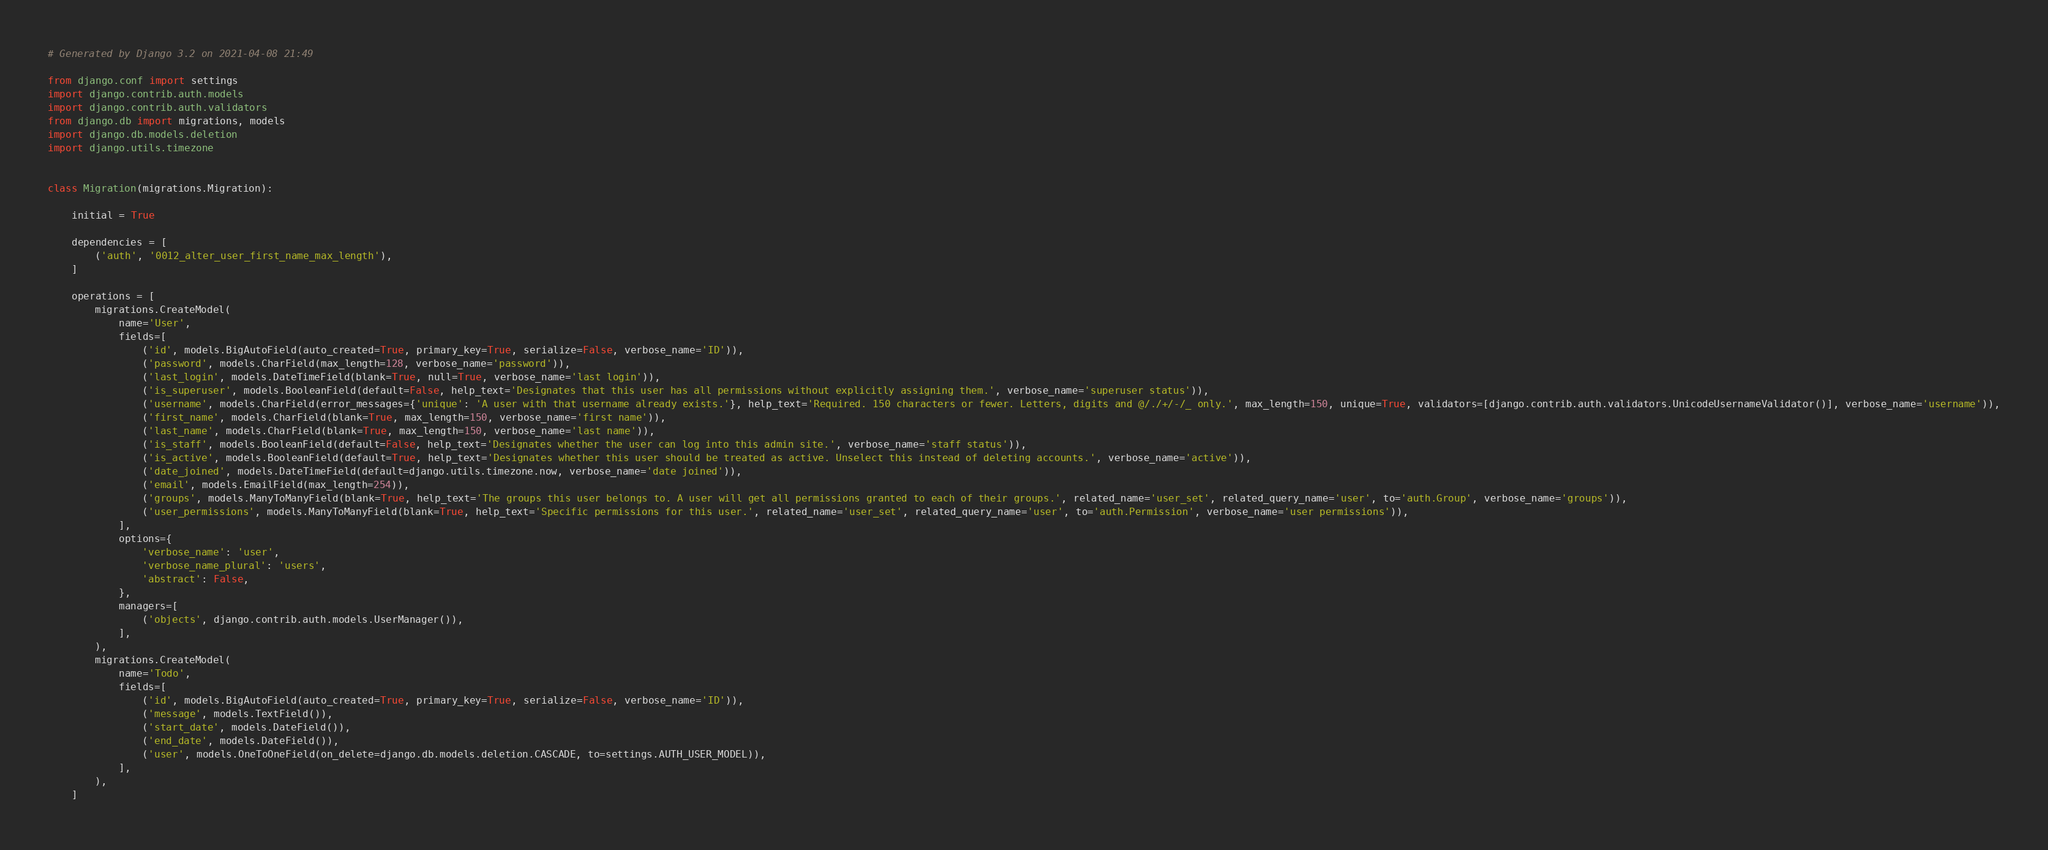<code> <loc_0><loc_0><loc_500><loc_500><_Python_># Generated by Django 3.2 on 2021-04-08 21:49

from django.conf import settings
import django.contrib.auth.models
import django.contrib.auth.validators
from django.db import migrations, models
import django.db.models.deletion
import django.utils.timezone


class Migration(migrations.Migration):

    initial = True

    dependencies = [
        ('auth', '0012_alter_user_first_name_max_length'),
    ]

    operations = [
        migrations.CreateModel(
            name='User',
            fields=[
                ('id', models.BigAutoField(auto_created=True, primary_key=True, serialize=False, verbose_name='ID')),
                ('password', models.CharField(max_length=128, verbose_name='password')),
                ('last_login', models.DateTimeField(blank=True, null=True, verbose_name='last login')),
                ('is_superuser', models.BooleanField(default=False, help_text='Designates that this user has all permissions without explicitly assigning them.', verbose_name='superuser status')),
                ('username', models.CharField(error_messages={'unique': 'A user with that username already exists.'}, help_text='Required. 150 characters or fewer. Letters, digits and @/./+/-/_ only.', max_length=150, unique=True, validators=[django.contrib.auth.validators.UnicodeUsernameValidator()], verbose_name='username')),
                ('first_name', models.CharField(blank=True, max_length=150, verbose_name='first name')),
                ('last_name', models.CharField(blank=True, max_length=150, verbose_name='last name')),
                ('is_staff', models.BooleanField(default=False, help_text='Designates whether the user can log into this admin site.', verbose_name='staff status')),
                ('is_active', models.BooleanField(default=True, help_text='Designates whether this user should be treated as active. Unselect this instead of deleting accounts.', verbose_name='active')),
                ('date_joined', models.DateTimeField(default=django.utils.timezone.now, verbose_name='date joined')),
                ('email', models.EmailField(max_length=254)),
                ('groups', models.ManyToManyField(blank=True, help_text='The groups this user belongs to. A user will get all permissions granted to each of their groups.', related_name='user_set', related_query_name='user', to='auth.Group', verbose_name='groups')),
                ('user_permissions', models.ManyToManyField(blank=True, help_text='Specific permissions for this user.', related_name='user_set', related_query_name='user', to='auth.Permission', verbose_name='user permissions')),
            ],
            options={
                'verbose_name': 'user',
                'verbose_name_plural': 'users',
                'abstract': False,
            },
            managers=[
                ('objects', django.contrib.auth.models.UserManager()),
            ],
        ),
        migrations.CreateModel(
            name='Todo',
            fields=[
                ('id', models.BigAutoField(auto_created=True, primary_key=True, serialize=False, verbose_name='ID')),
                ('message', models.TextField()),
                ('start_date', models.DateField()),
                ('end_date', models.DateField()),
                ('user', models.OneToOneField(on_delete=django.db.models.deletion.CASCADE, to=settings.AUTH_USER_MODEL)),
            ],
        ),
    ]
</code> 